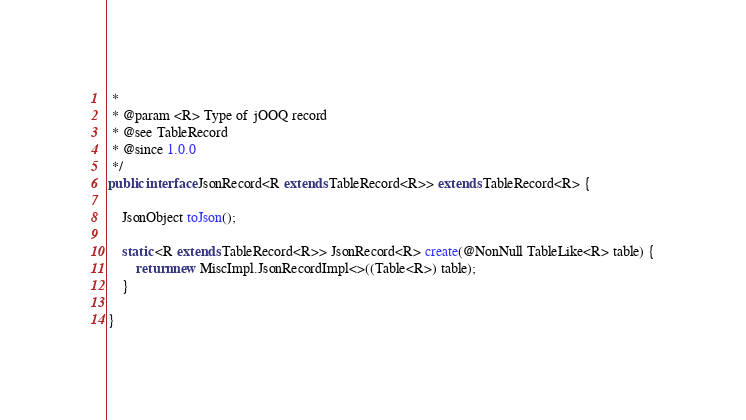Convert code to text. <code><loc_0><loc_0><loc_500><loc_500><_Java_> *
 * @param <R> Type of jOOQ record
 * @see TableRecord
 * @since 1.0.0
 */
public interface JsonRecord<R extends TableRecord<R>> extends TableRecord<R> {

    JsonObject toJson();

    static <R extends TableRecord<R>> JsonRecord<R> create(@NonNull TableLike<R> table) {
        return new MiscImpl.JsonRecordImpl<>((Table<R>) table);
    }

}
</code> 